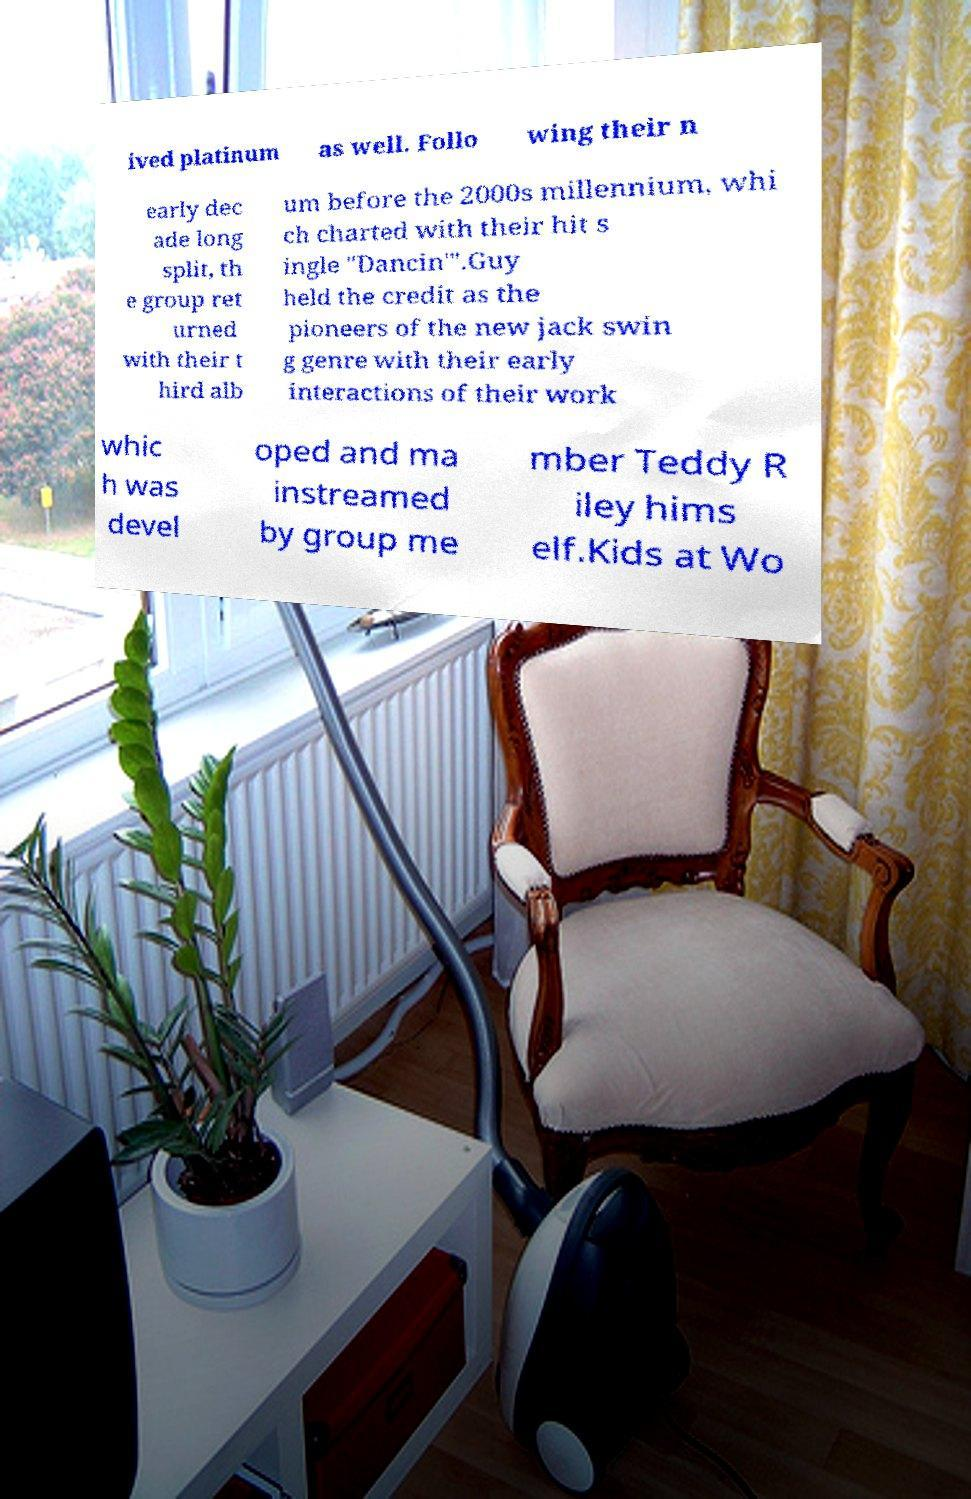Could you assist in decoding the text presented in this image and type it out clearly? ived platinum as well. Follo wing their n early dec ade long split, th e group ret urned with their t hird alb um before the 2000s millennium, whi ch charted with their hit s ingle "Dancin'".Guy held the credit as the pioneers of the new jack swin g genre with their early interactions of their work whic h was devel oped and ma instreamed by group me mber Teddy R iley hims elf.Kids at Wo 